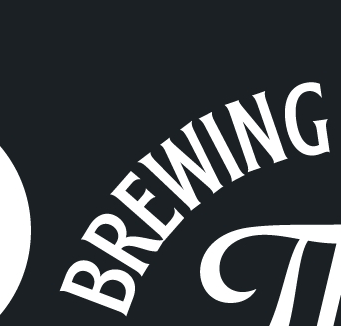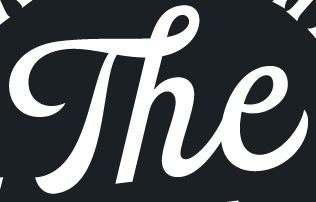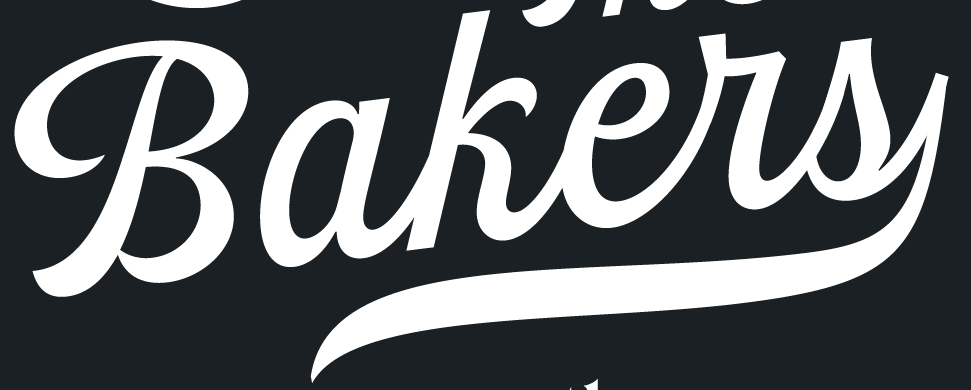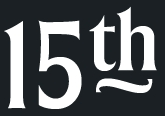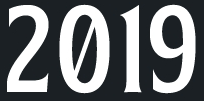Transcribe the words shown in these images in order, separated by a semicolon. BREWING; The; Bakers; 15th; 2019 